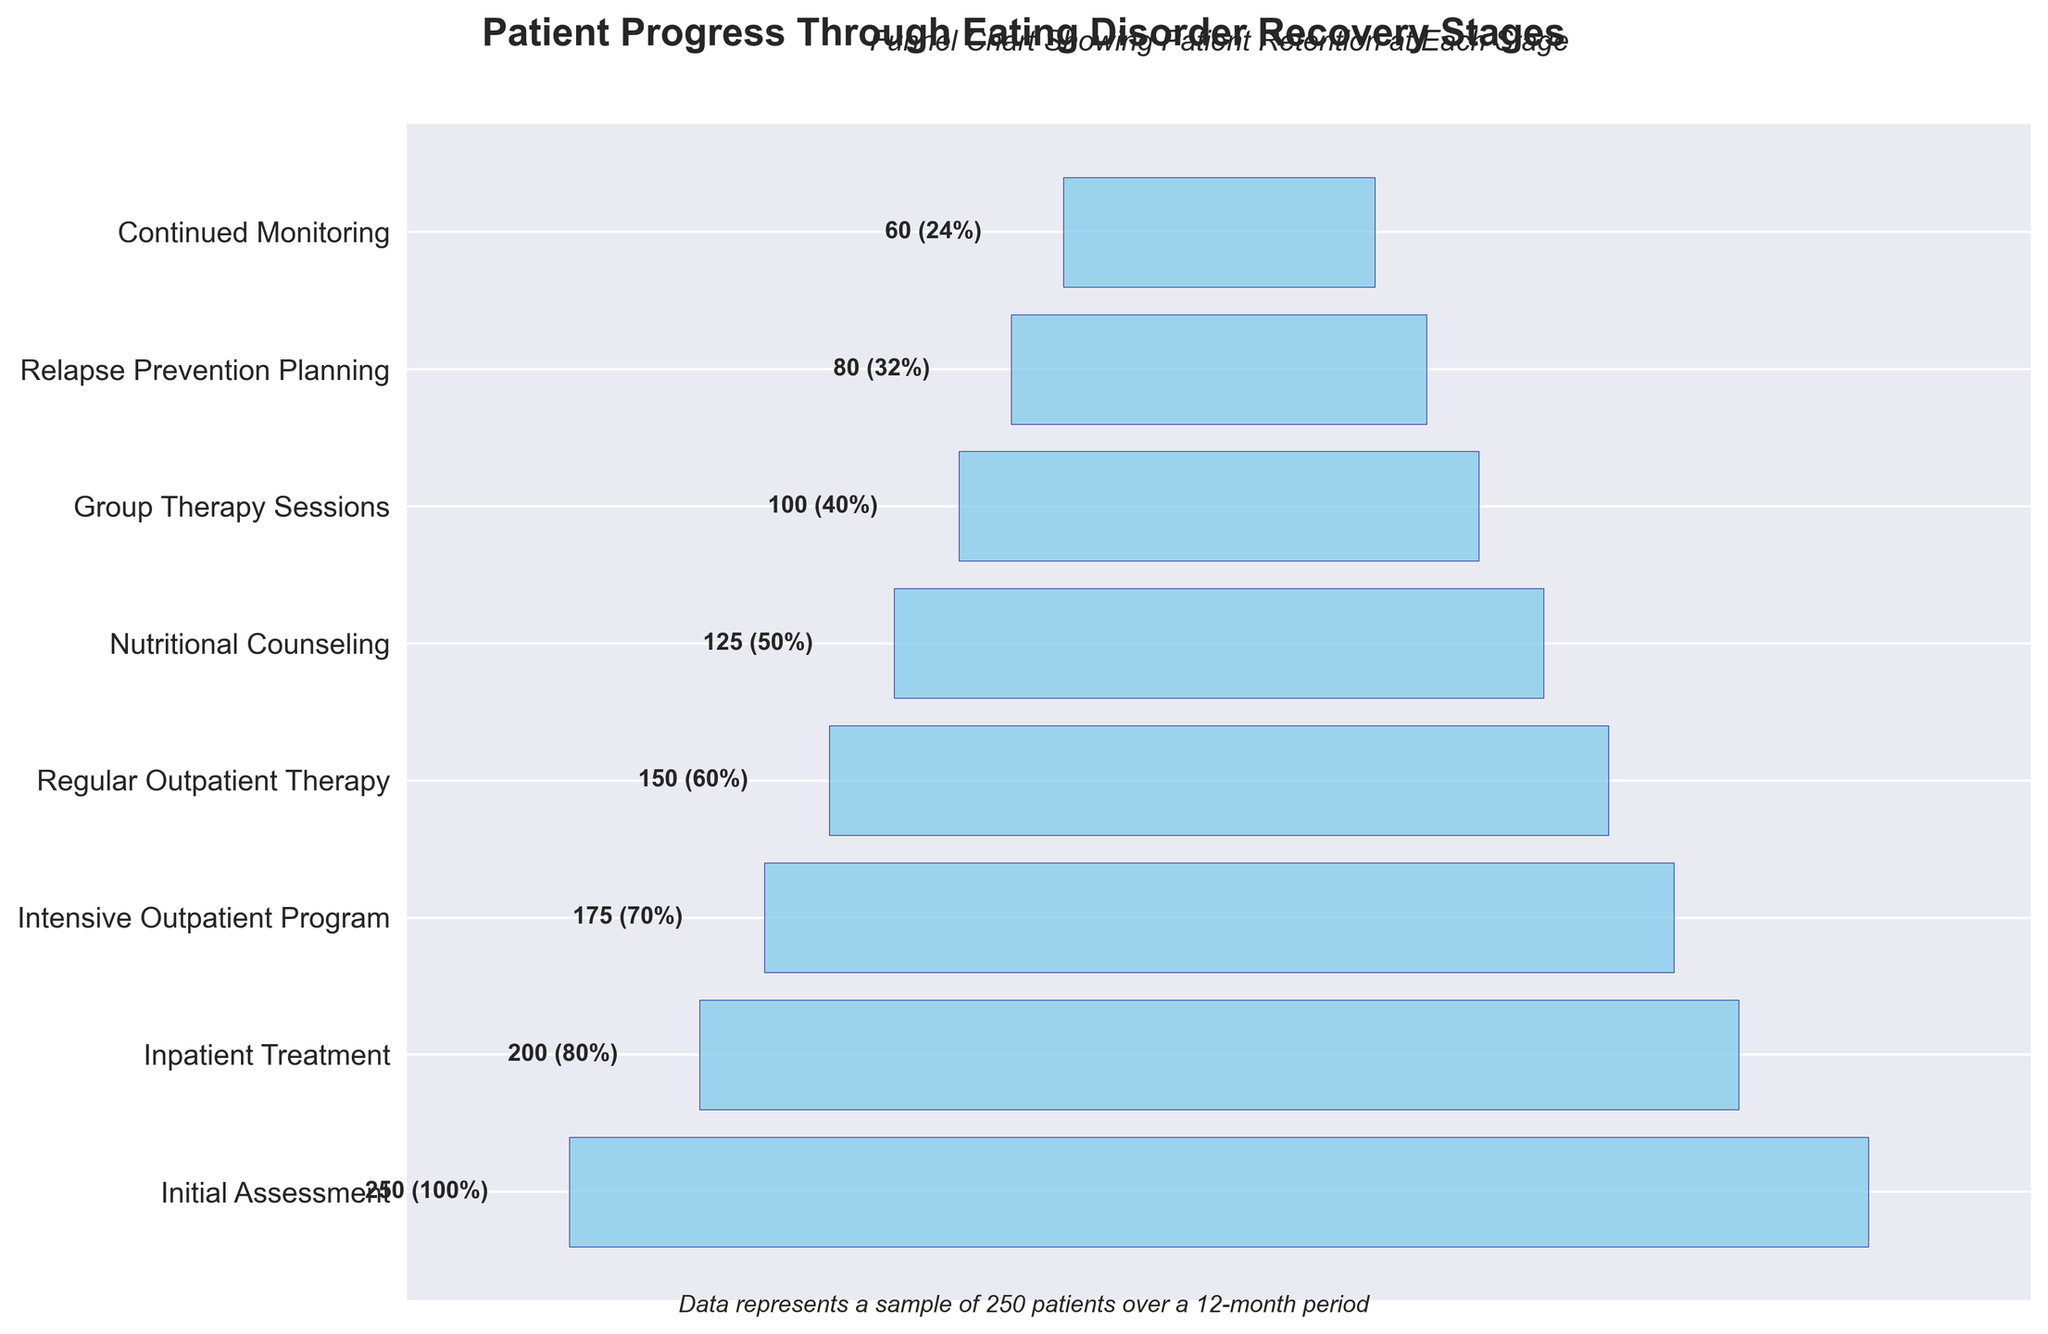What is the title of the chart? The title is prominently displayed at the top of the chart. It reads "Patient Progress Through Eating Disorder Recovery Stages".
Answer: "Patient Progress Through Eating Disorder Recovery Stages" How many stages are represented in the funnel chart? You can count the different stages listed on the y-axis which are labeled from top to bottom. By counting each label, you find there are 8 stages.
Answer: 8 Which stage has the highest number of patients? The highest number of patients corresponds to the bar with the largest width. The bar at the top, labeled "Initial Assessment," has the largest number of patients, indicated by the number 250.
Answer: Initial Assessment How many patients advance from the "Inpatient Treatment" to the "Intensive Outpatient Program" stage? To find this, look at the number of patients in the "Inpatient Treatment" stage (200) and compare it to the number of patients in the "Intensive Outpatient Program" stage (175). The difference between these two numbers gives the number of patients who advanced to the next stage. 200 - 175 = 25
Answer: 25 What percentage of patients remain at the "Nutritional Counseling" stage compared to the "Initial Assessment" stage? The number of patients at "Nutritional Counseling" is 125. To find the percentage compared to the "Initial Assessment" stage, which has 250 patients, calculate (125 / 250) * 100%.
Answer: 50% How many patients drop out between "Group Therapy Sessions" and "Relapse Prevention Planning"? The number of patients in "Group Therapy Sessions" is 100 and in "Relapse Prevention Planning" is 80. Subtract the latter from the former to find the dropout number: 100 - 80 = 20.
Answer: 20 Is the number of patients in "Continued Monitoring" more or less than half of the number in "Regular Outpatient Therapy"? There are 60 patients in "Continued Monitoring" and 150 in "Regular Outpatient Therapy". Half of 150 is 75. Since 60 is less than 75, the patients in "Continued Monitoring" are less than half of those in "Regular Outpatient Therapy".
Answer: Less What is the difference in patient numbers between the stage with the maximum and minimum patients? The maximum number of patients is in "Initial Assessment" (250), and the minimum is in "Continued Monitoring" (60). The difference is 250 - 60 = 190.
Answer: 190 What proportion of patients advance from "Initial Assessment" to "Continued Monitoring"? To find the proportion, observe the numbers in both stages: 60 patients in "Continued Monitoring" out of the original 250 in "Initial Assessment". Calculate the proportion as 60 / 250 = 0.24 or 24%.
Answer: 24% Between which two consecutive stages is the biggest drop in patient numbers? Observing the patient numbers at each stage, the biggest drop is between "Regular Outpatient Therapy" (150) and "Nutritional Counseling" (125). Calculate the difference: 150 - 125 = 25.
Answer: "Regular Outpatient Therapy" to "Nutritional Counseling" 